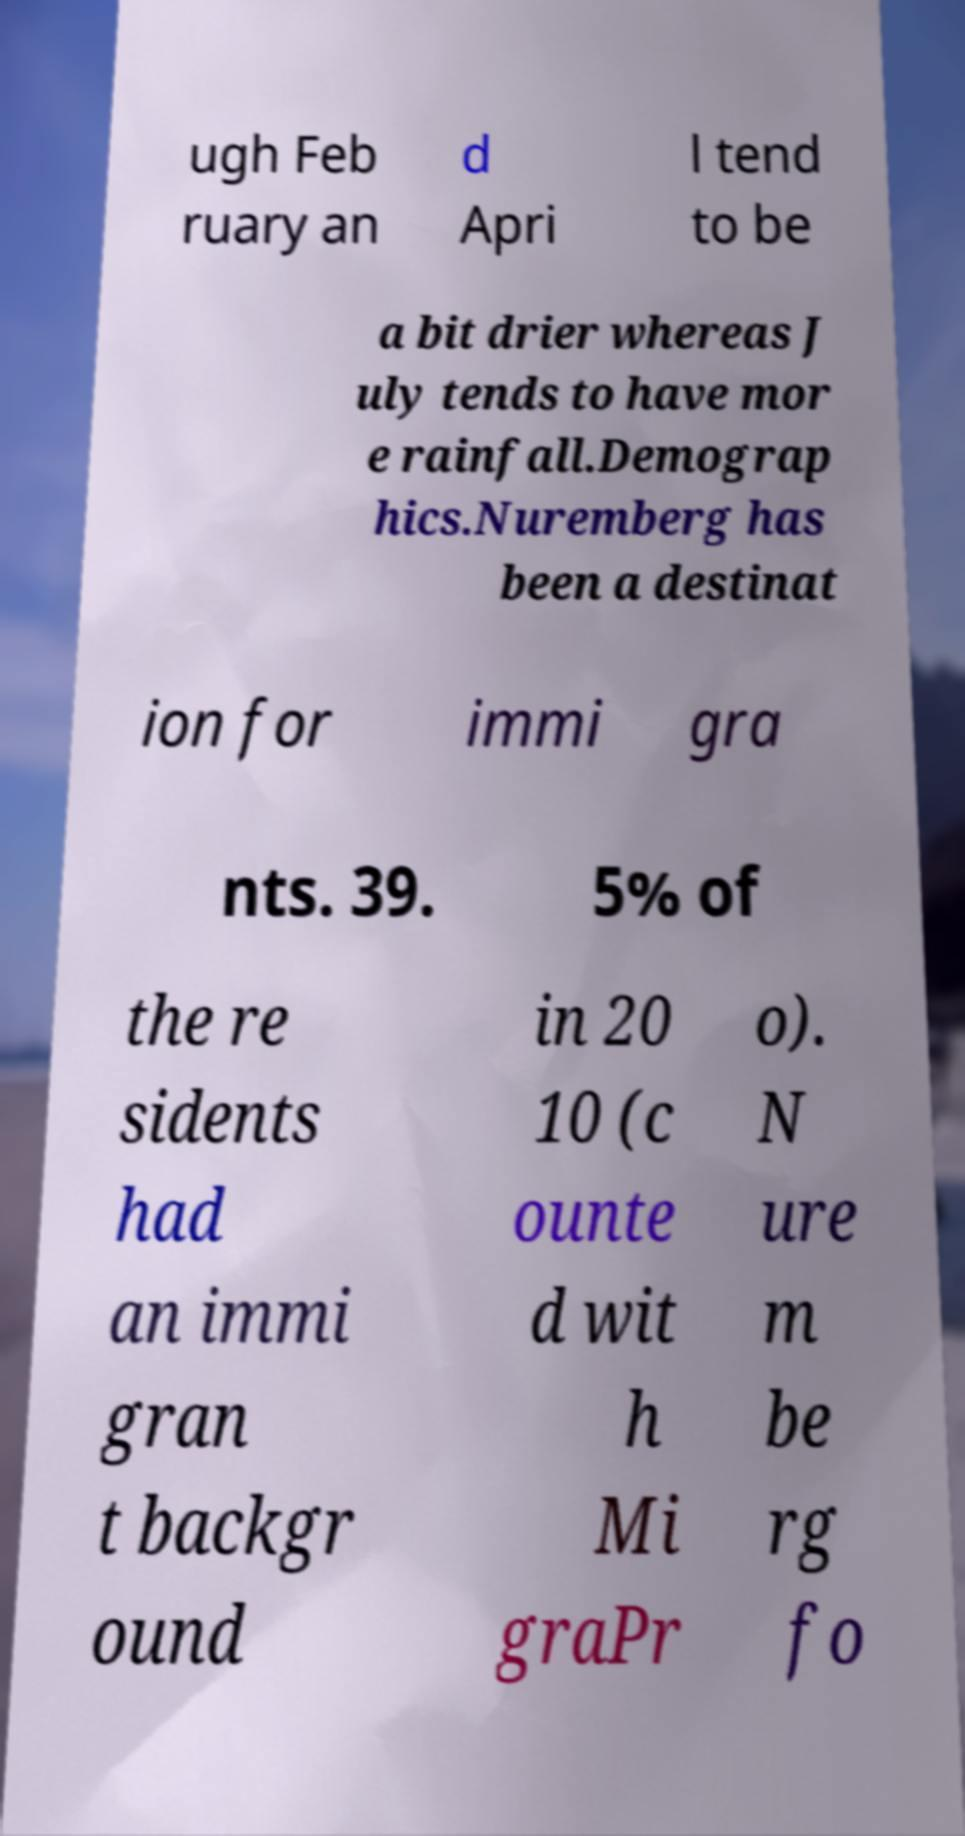Could you extract and type out the text from this image? ugh Feb ruary an d Apri l tend to be a bit drier whereas J uly tends to have mor e rainfall.Demograp hics.Nuremberg has been a destinat ion for immi gra nts. 39. 5% of the re sidents had an immi gran t backgr ound in 20 10 (c ounte d wit h Mi graPr o). N ure m be rg fo 